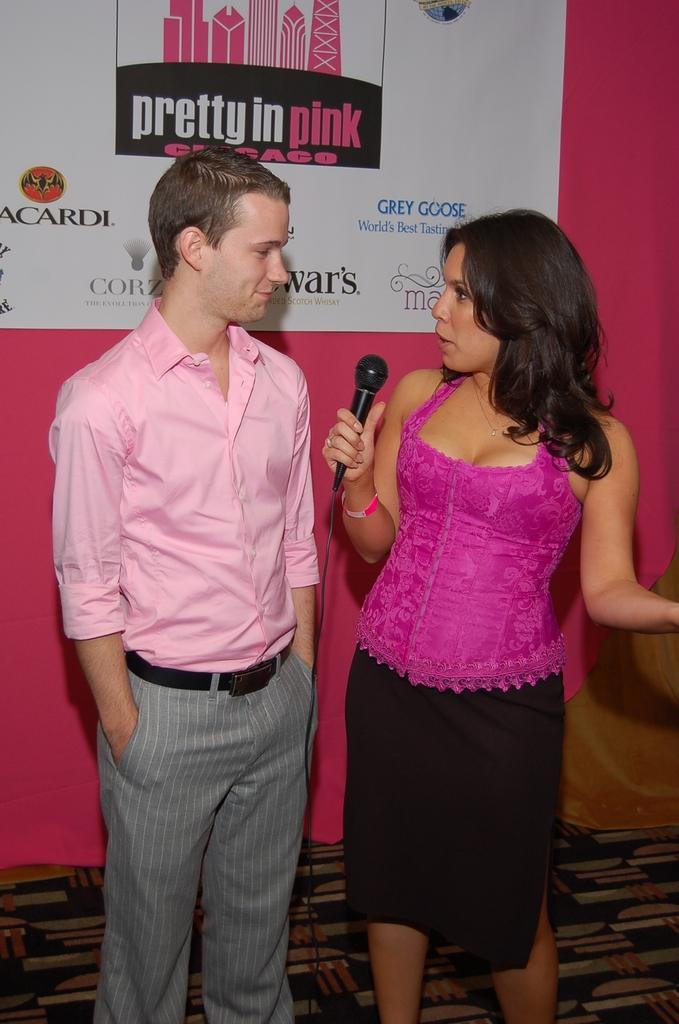How many people are in the image? There are two persons standing in the image. What is one person holding in the image? One person is holding a microphone. What can be seen in the background of the image? There is a banner visible in the background. What type of surface is visible in the image? The image shows a floor. Are the two persons in the image brothers? There is no information in the image to determine if the two persons are brothers. Is there a veil visible in the image? No, there is no veil present in the image. 